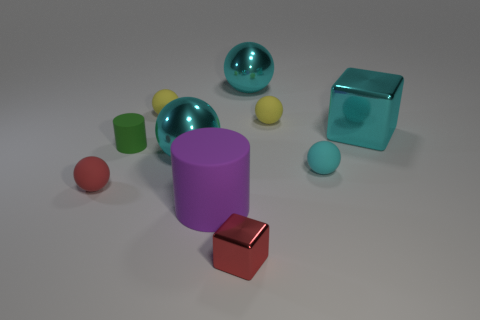Subtract all brown cubes. How many cyan balls are left? 3 Subtract all matte spheres. How many spheres are left? 2 Subtract all yellow spheres. How many spheres are left? 4 Subtract 2 balls. How many balls are left? 4 Subtract all purple spheres. Subtract all purple cylinders. How many spheres are left? 6 Subtract all balls. How many objects are left? 4 Add 4 big cylinders. How many big cylinders exist? 5 Subtract 0 green spheres. How many objects are left? 10 Subtract all small yellow metal cylinders. Subtract all cyan shiny blocks. How many objects are left? 9 Add 4 cyan metallic objects. How many cyan metallic objects are left? 7 